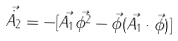Convert formula to latex. <formula><loc_0><loc_0><loc_500><loc_500>\vec { \dot { A _ { 2 } } } = - [ \vec { A _ { 1 } } \vec { \phi ^ { 2 } } - \vec { \phi } ( \vec { A _ { 1 } } \cdot \vec { \phi } ) ]</formula> 